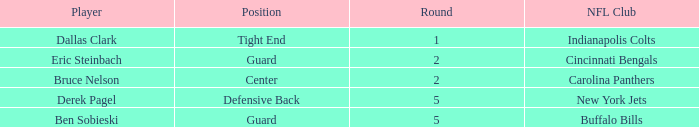In what round was a player from the hawkeyes picked for the defensive back position? 5.0. 